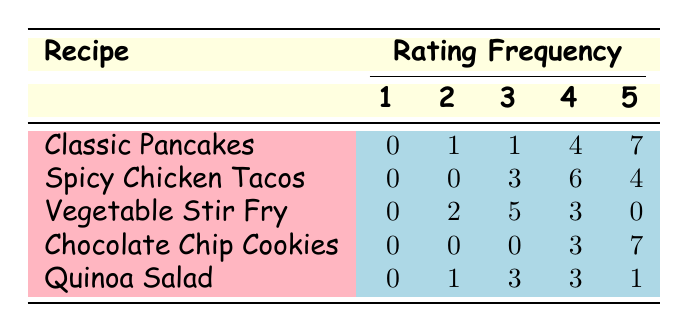What is the highest rating frequency for Classic Pancakes? In the row for Classic Pancakes, we can see that the highest rating of 5 has a frequency of 7. This means that 7 viewers rated the Classic Pancakes with a score of 5.
Answer: 7 What rating did the Vegetable Stir Fry receive the most? Looking at the row for Vegetable Stir Fry, the rating with the highest frequency is 3, which has a total of 5 viewers giving that rating.
Answer: 3 How many total viewers rated the Spicy Chicken Tacos? The table shows that the total number of viewers for Spicy Chicken Tacos is 850, which means this is the overall sum of viewers who rated this dish.
Answer: 850 Can you find the average rating for Chocolate Chip Cookies? To find the average rating for Chocolate Chip Cookies, we add the rating values weighted by their frequencies: (0*1 + 0*2 + 0*3 + 3*4 + 7*5) / (0+0+0+3+7) = (0 + 0 + 0 + 12 + 35) / 10 = 47 / 10 = 4.7.
Answer: 4.7 Do any recipes have a rating of 1? Checking the frequencies for all recipes, we find that none of the recipes have a frequency for rating 1; therefore, the answer is no.
Answer: No Which recipe had the most viewers who rated it a 4? Looking at the frequencies for rating 4, Classic Pancakes had 4 viewers rating it a 4, Spicy Chicken Tacos had 6, Vegetable Stir Fry had 3, Chocolate Chip Cookies had 3, and Quinoa Salad had 3. The recipe with the most viewers who rated it 4 is Spicy Chicken Tacos with 6.
Answer: Spicy Chicken Tacos What is the total frequency of ratings for the Quinoa Salad? In the row for Quinoa Salad, the frequencies of ratings are: 0 (for 1), 1 (for 2), 3 (for 3), 3 (for 4), and 1 (for 5). Adding these gives us a total frequency of 0+1+3+3+1 = 8. This reflects the total ratings given to Quinoa Salad.
Answer: 8 What percentage of viewers gave a rating of 5 for Chocolate Chip Cookies? For Chocolate Chip Cookies, the frequency of 5 ratings is 7 out of a total of 10 ratings (0+0+0+3+7). To find the percentage, we calculate (7/10) * 100 = 70%. So, 70% of viewers rated it a 5.
Answer: 70% 